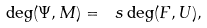Convert formula to latex. <formula><loc_0><loc_0><loc_500><loc_500>\deg ( \Psi , M ) = \ s \deg ( F , U ) ,</formula> 